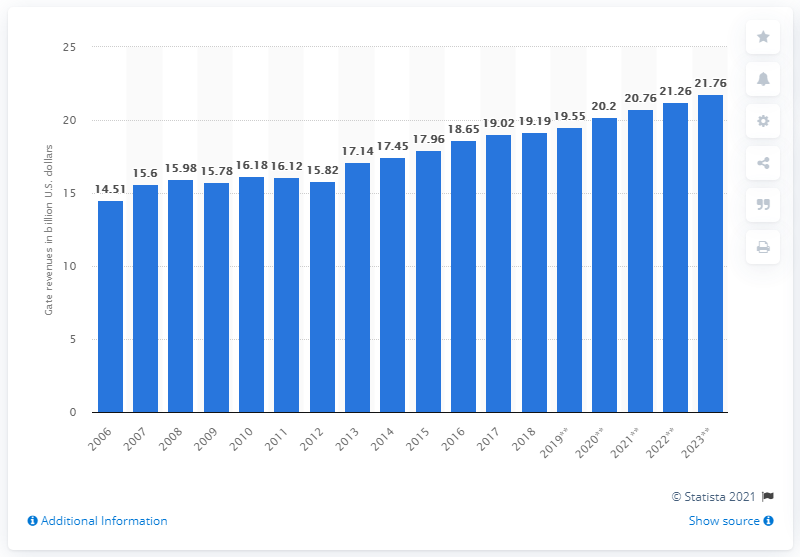List a handful of essential elements in this visual. In 2018, the total amount of sports gate revenues in North America was 19.19 billion dollars. 